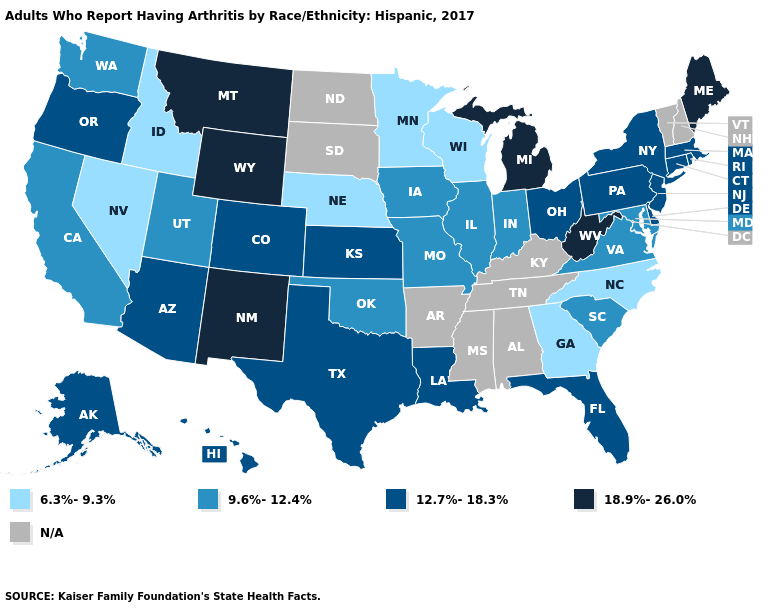Name the states that have a value in the range 9.6%-12.4%?
Concise answer only. California, Illinois, Indiana, Iowa, Maryland, Missouri, Oklahoma, South Carolina, Utah, Virginia, Washington. Does the map have missing data?
Keep it brief. Yes. What is the highest value in states that border Kansas?
Concise answer only. 12.7%-18.3%. Name the states that have a value in the range 9.6%-12.4%?
Answer briefly. California, Illinois, Indiana, Iowa, Maryland, Missouri, Oklahoma, South Carolina, Utah, Virginia, Washington. Name the states that have a value in the range N/A?
Be succinct. Alabama, Arkansas, Kentucky, Mississippi, New Hampshire, North Dakota, South Dakota, Tennessee, Vermont. What is the lowest value in states that border Wyoming?
Write a very short answer. 6.3%-9.3%. Among the states that border Arizona , does Nevada have the highest value?
Give a very brief answer. No. Among the states that border Colorado , does Nebraska have the lowest value?
Concise answer only. Yes. What is the value of Maine?
Short answer required. 18.9%-26.0%. Name the states that have a value in the range 18.9%-26.0%?
Answer briefly. Maine, Michigan, Montana, New Mexico, West Virginia, Wyoming. Name the states that have a value in the range N/A?
Answer briefly. Alabama, Arkansas, Kentucky, Mississippi, New Hampshire, North Dakota, South Dakota, Tennessee, Vermont. What is the lowest value in the West?
Give a very brief answer. 6.3%-9.3%. Does the first symbol in the legend represent the smallest category?
Give a very brief answer. Yes. Among the states that border Wisconsin , which have the highest value?
Give a very brief answer. Michigan. What is the value of Colorado?
Give a very brief answer. 12.7%-18.3%. 